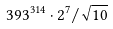<formula> <loc_0><loc_0><loc_500><loc_500>3 9 3 ^ { 3 1 4 } \cdot 2 ^ { 7 } / \sqrt { 1 0 }</formula> 